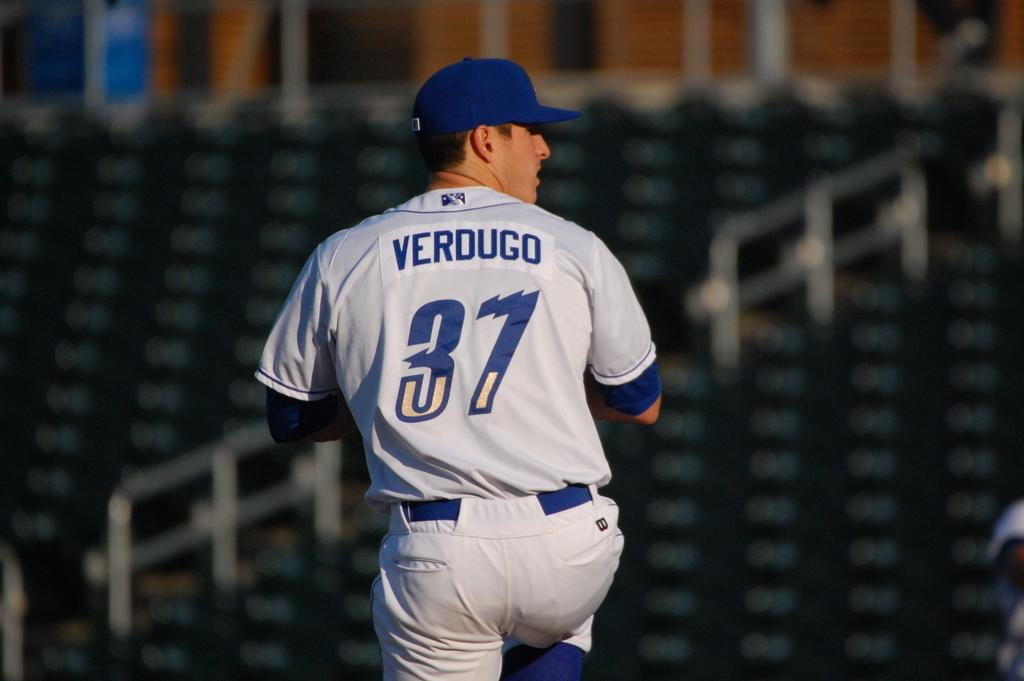<image>
Describe the image concisely. Verdugo is wearing 37 and about to throw a pitch 